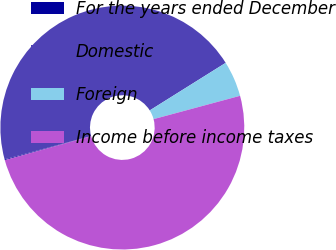<chart> <loc_0><loc_0><loc_500><loc_500><pie_chart><fcel>For the years ended December<fcel>Domestic<fcel>Foreign<fcel>Income before income taxes<nl><fcel>0.11%<fcel>45.29%<fcel>4.71%<fcel>49.89%<nl></chart> 